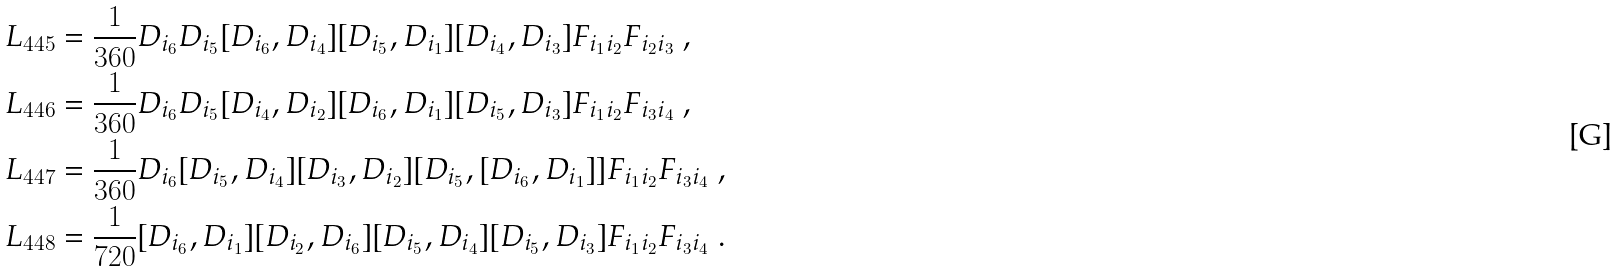Convert formula to latex. <formula><loc_0><loc_0><loc_500><loc_500>L _ { 4 4 5 } & = \frac { 1 } { 3 6 0 } D _ { i _ { 6 } } D _ { i _ { 5 } } [ D _ { i _ { 6 } } , D _ { i _ { 4 } } ] [ D _ { i _ { 5 } } , D _ { i _ { 1 } } ] [ D _ { i _ { 4 } } , D _ { i _ { 3 } } ] F _ { i _ { 1 } i _ { 2 } } F _ { i _ { 2 } i _ { 3 } } \ , \\ L _ { 4 4 6 } & = \frac { 1 } { 3 6 0 } D _ { i _ { 6 } } D _ { i _ { 5 } } [ D _ { i _ { 4 } } , D _ { i _ { 2 } } ] [ D _ { i _ { 6 } } , D _ { i _ { 1 } } ] [ D _ { i _ { 5 } } , D _ { i _ { 3 } } ] F _ { i _ { 1 } i _ { 2 } } F _ { i _ { 3 } i _ { 4 } } \ , \\ L _ { 4 4 7 } & = \frac { 1 } { 3 6 0 } D _ { i _ { 6 } } [ D _ { i _ { 5 } } , D _ { i _ { 4 } } ] [ D _ { i _ { 3 } } , D _ { i _ { 2 } } ] [ D _ { i _ { 5 } } , [ D _ { i _ { 6 } } , D _ { i _ { 1 } } ] ] F _ { i _ { 1 } i _ { 2 } } F _ { i _ { 3 } i _ { 4 } } \ , \\ L _ { 4 4 8 } & = \frac { 1 } { 7 2 0 } [ D _ { i _ { 6 } } , D _ { i _ { 1 } } ] [ D _ { i _ { 2 } } , D _ { i _ { 6 } } ] [ D _ { i _ { 5 } } , D _ { i _ { 4 } } ] [ D _ { i _ { 5 } } , D _ { i _ { 3 } } ] F _ { i _ { 1 } i _ { 2 } } F _ { i _ { 3 } i _ { 4 } } \ .</formula> 